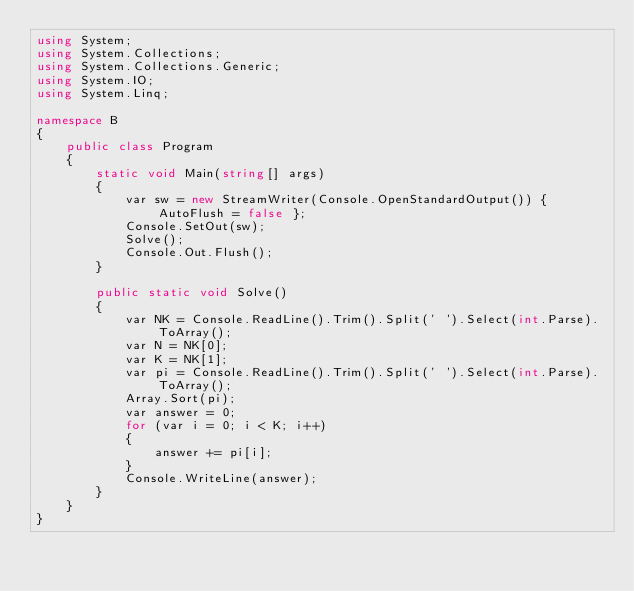<code> <loc_0><loc_0><loc_500><loc_500><_C#_>using System;
using System.Collections;
using System.Collections.Generic;
using System.IO;
using System.Linq;

namespace B
{
    public class Program
    {
        static void Main(string[] args)
        {
            var sw = new StreamWriter(Console.OpenStandardOutput()) { AutoFlush = false };
            Console.SetOut(sw);
            Solve();
            Console.Out.Flush();
        }

        public static void Solve()
        {
            var NK = Console.ReadLine().Trim().Split(' ').Select(int.Parse).ToArray();
            var N = NK[0];
            var K = NK[1];
            var pi = Console.ReadLine().Trim().Split(' ').Select(int.Parse).ToArray();
            Array.Sort(pi);
            var answer = 0;
            for (var i = 0; i < K; i++)
            {
                answer += pi[i];
            }
            Console.WriteLine(answer);
        }
    }
}
</code> 